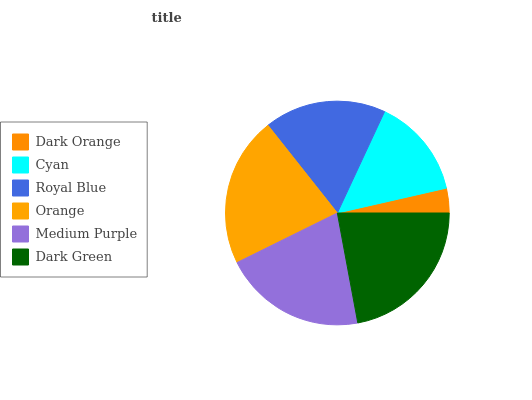Is Dark Orange the minimum?
Answer yes or no. Yes. Is Dark Green the maximum?
Answer yes or no. Yes. Is Cyan the minimum?
Answer yes or no. No. Is Cyan the maximum?
Answer yes or no. No. Is Cyan greater than Dark Orange?
Answer yes or no. Yes. Is Dark Orange less than Cyan?
Answer yes or no. Yes. Is Dark Orange greater than Cyan?
Answer yes or no. No. Is Cyan less than Dark Orange?
Answer yes or no. No. Is Medium Purple the high median?
Answer yes or no. Yes. Is Royal Blue the low median?
Answer yes or no. Yes. Is Dark Green the high median?
Answer yes or no. No. Is Orange the low median?
Answer yes or no. No. 